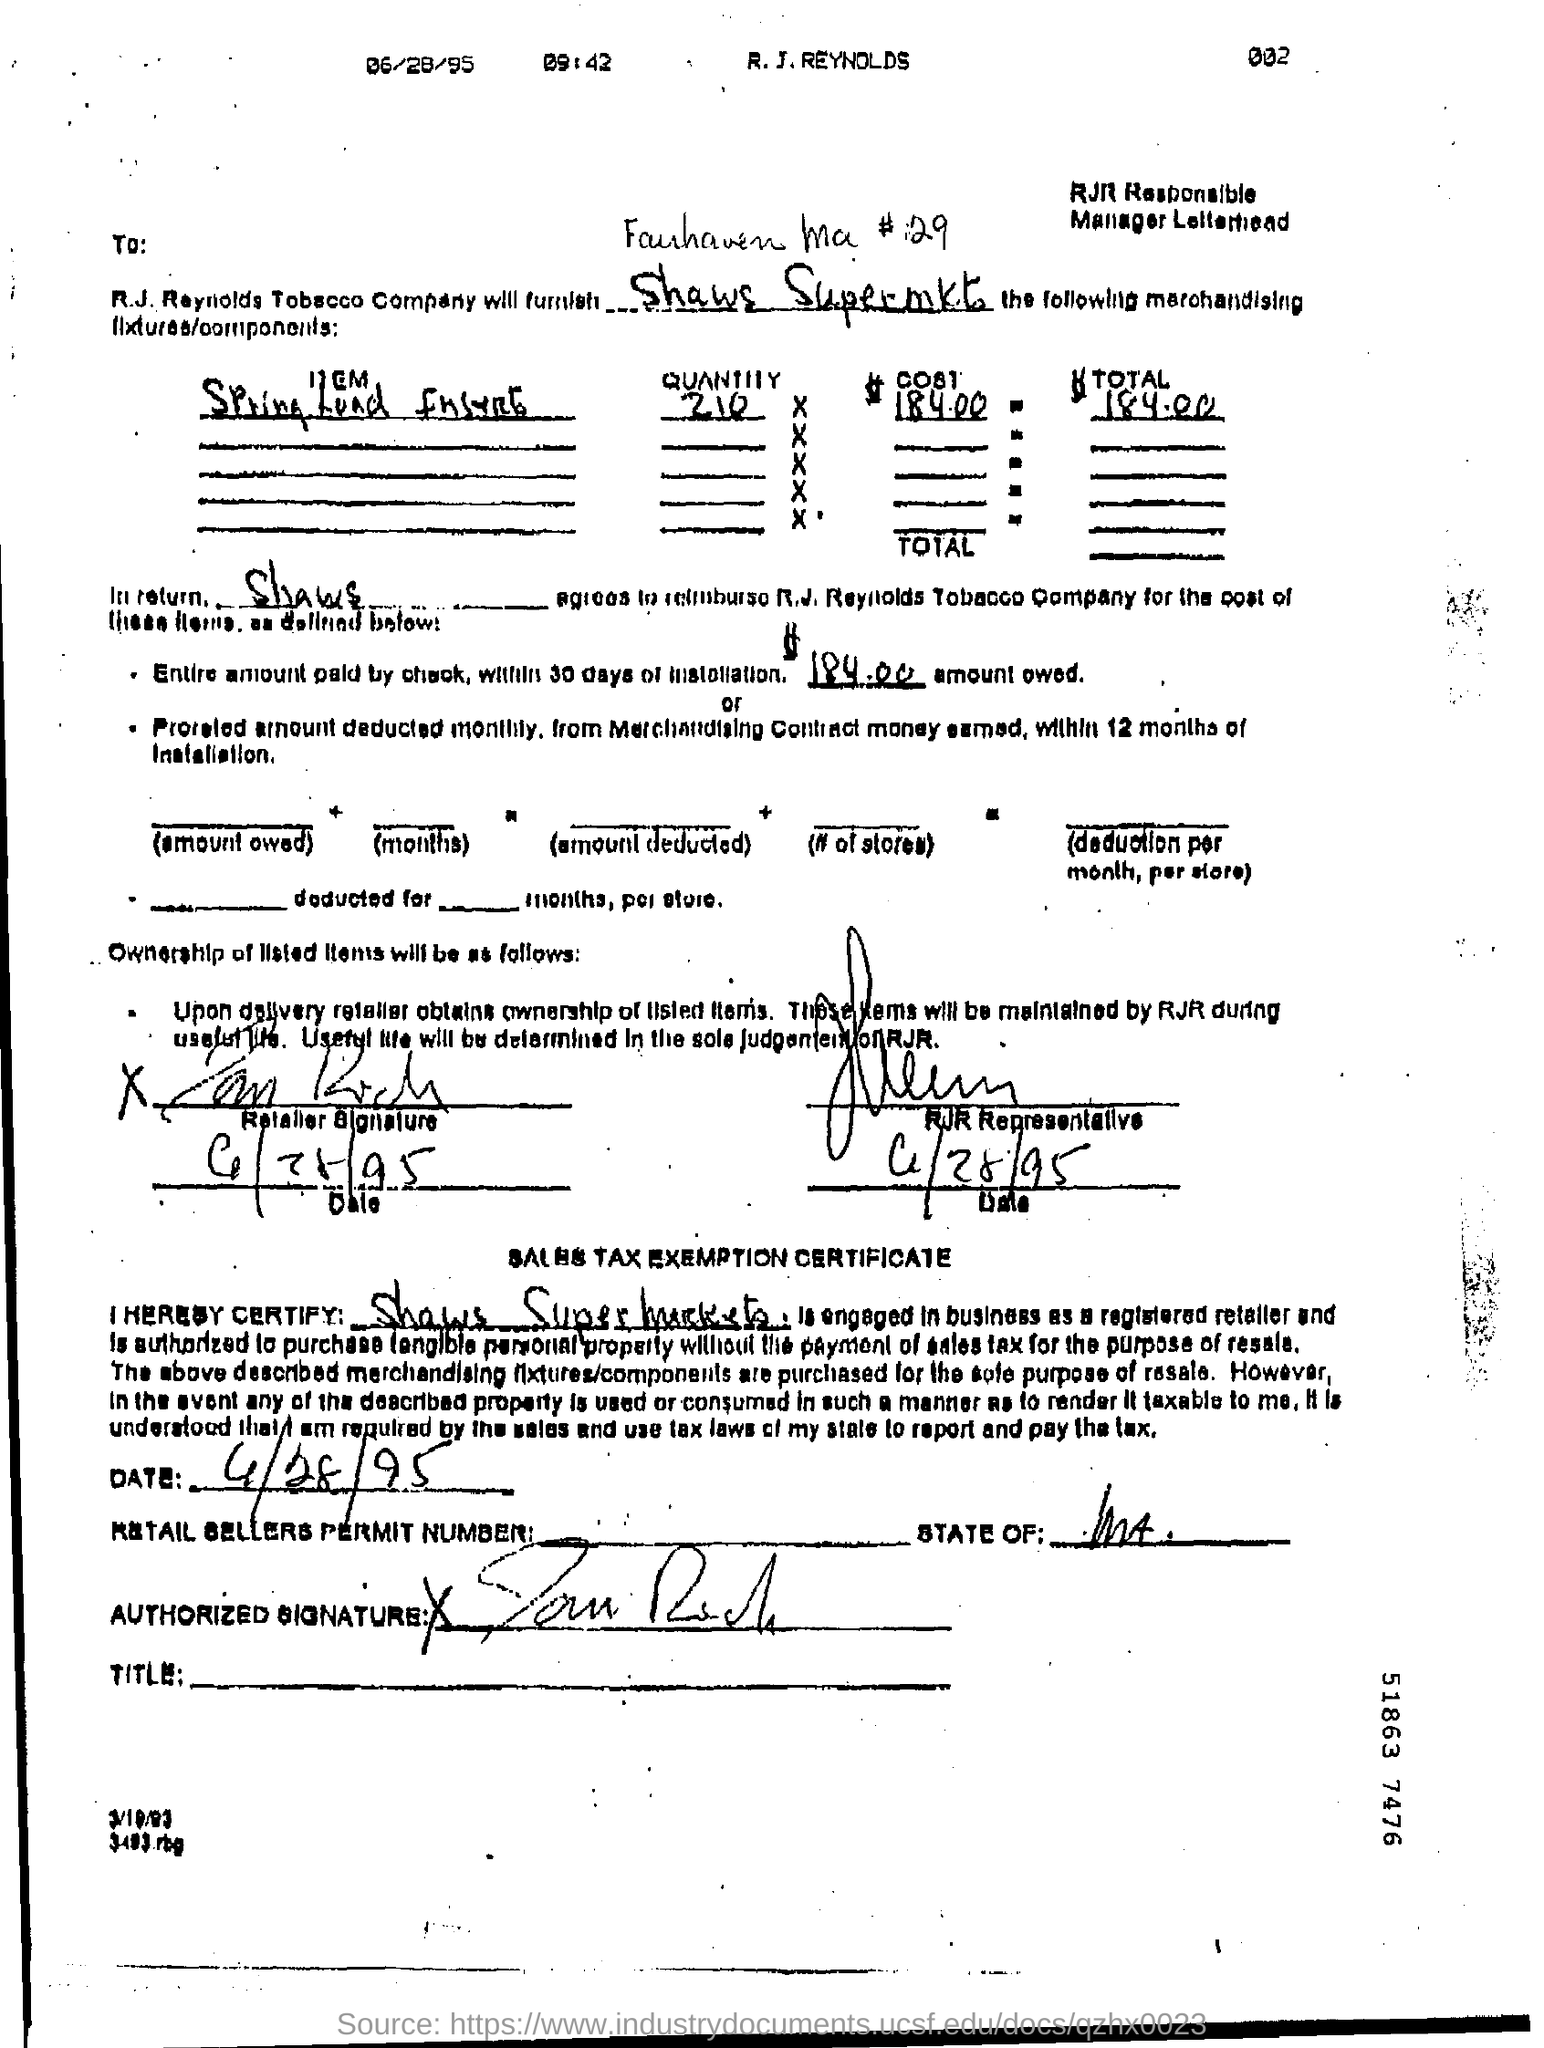Identify some key points in this picture. The total amount paid by check within 30 days of installation was $184.00. 